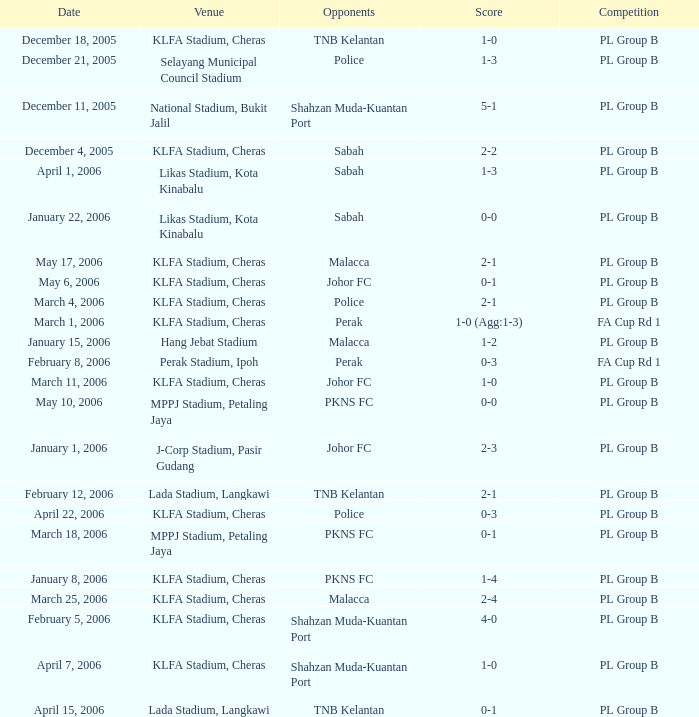Which event featured pkns fc's adversaries ending with a score of 0-0? PL Group B. 